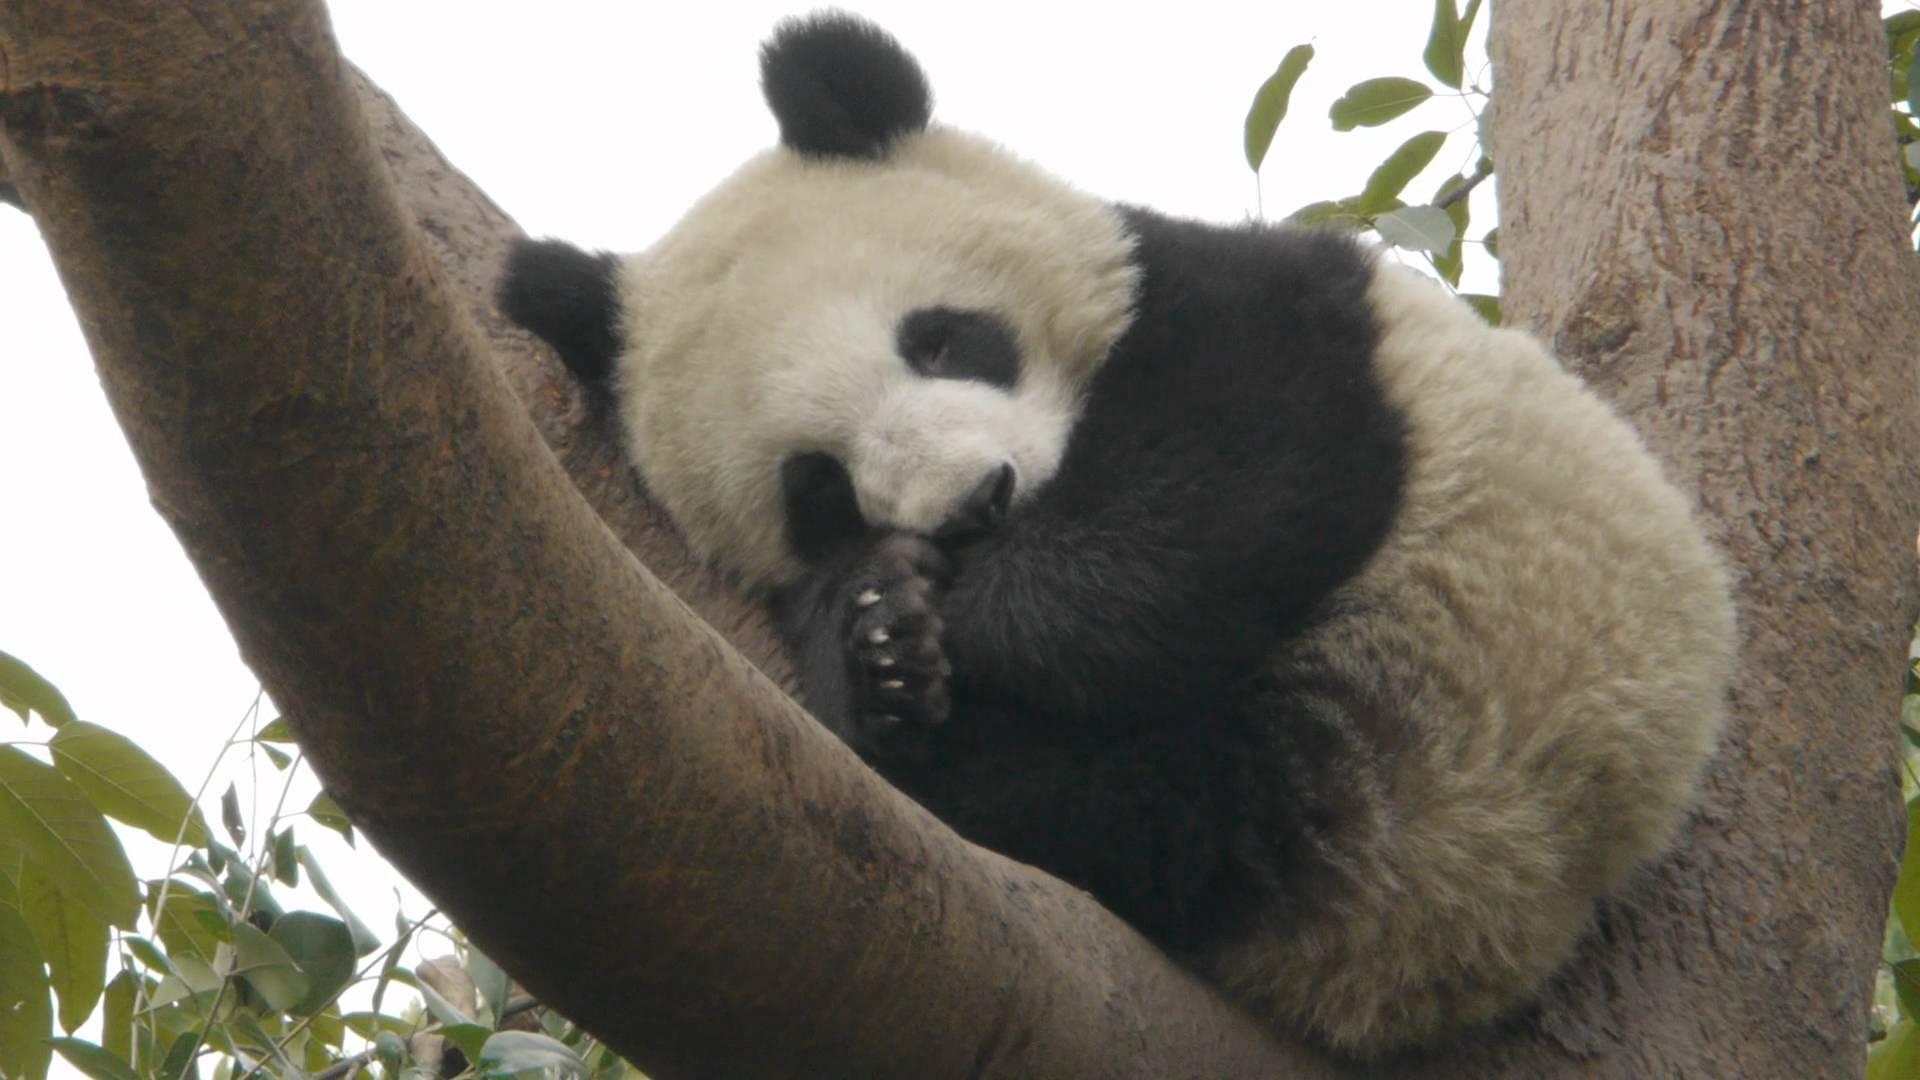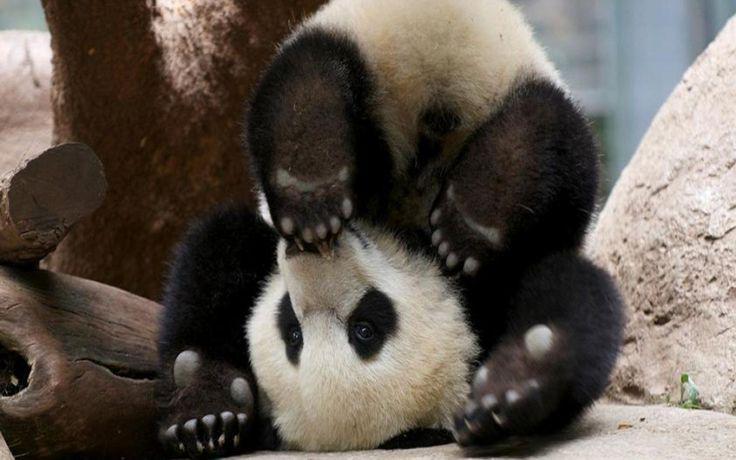The first image is the image on the left, the second image is the image on the right. Assess this claim about the two images: "There are three pandas in total.". Correct or not? Answer yes or no. No. The first image is the image on the left, the second image is the image on the right. For the images shown, is this caption "Images show a total of two panda bears relaxing in the branches of leafless trees." true? Answer yes or no. No. 